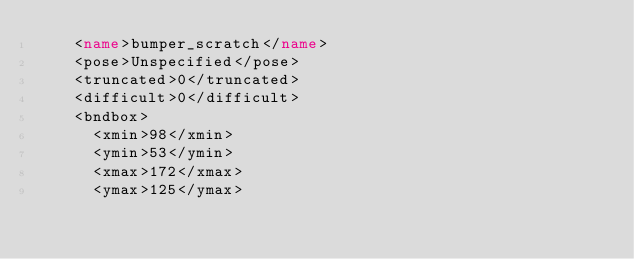Convert code to text. <code><loc_0><loc_0><loc_500><loc_500><_XML_>		<name>bumper_scratch</name>
		<pose>Unspecified</pose>
		<truncated>0</truncated>
		<difficult>0</difficult>
		<bndbox>
			<xmin>98</xmin>
			<ymin>53</ymin>
			<xmax>172</xmax>
			<ymax>125</ymax></code> 